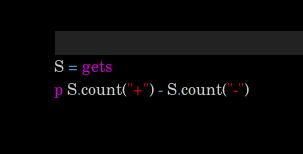Convert code to text. <code><loc_0><loc_0><loc_500><loc_500><_Ruby_>S = gets
p S.count("+") - S.count("-")</code> 